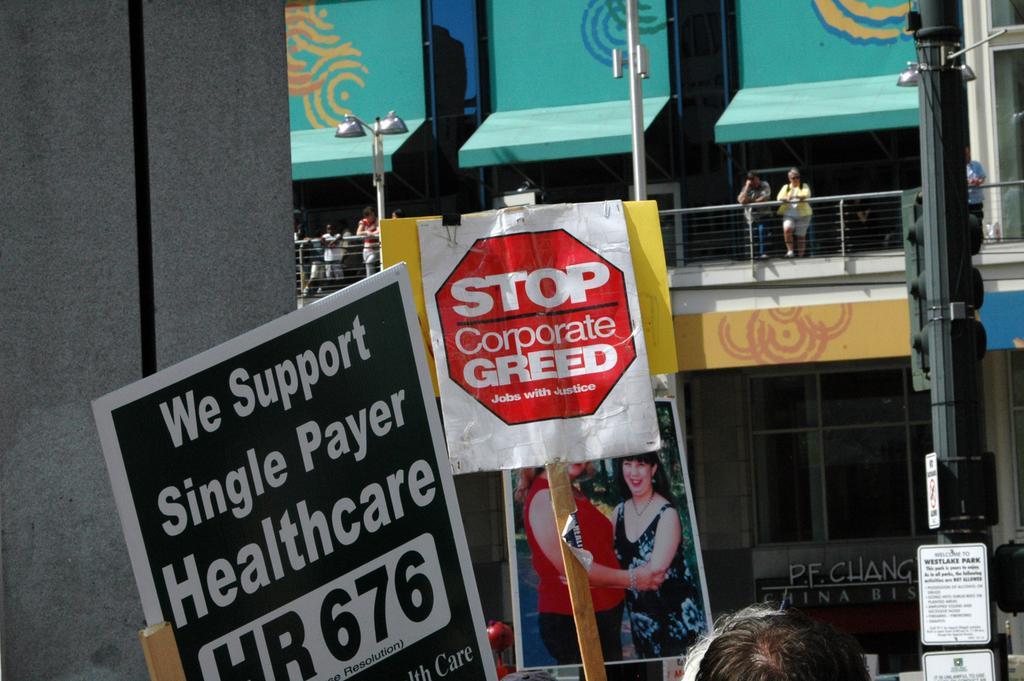How would you summarize this image in a sentence or two? In the picture there are few advertisement boards and in the front there are two heads of some people and in the background there is a building and few people were standing in the balcony of the building. 